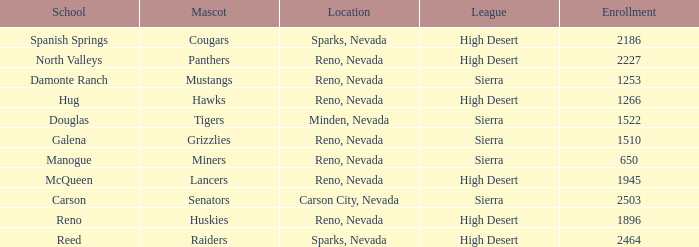Which leagues is the Galena school in? Sierra. 